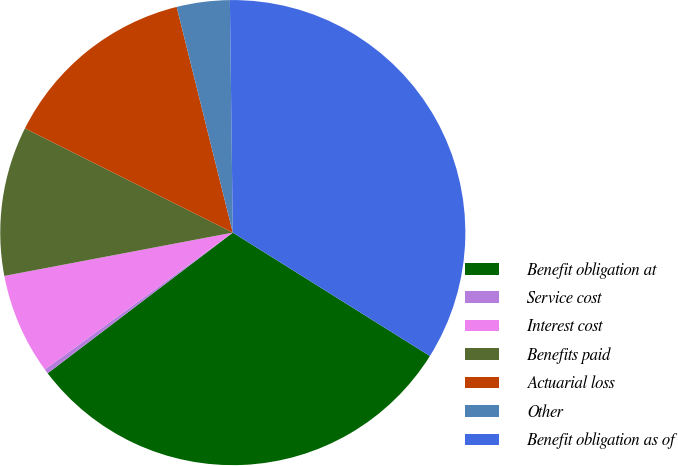Convert chart. <chart><loc_0><loc_0><loc_500><loc_500><pie_chart><fcel>Benefit obligation at<fcel>Service cost<fcel>Interest cost<fcel>Benefits paid<fcel>Actuarial loss<fcel>Other<fcel>Benefit obligation as of<nl><fcel>30.75%<fcel>0.33%<fcel>7.03%<fcel>10.38%<fcel>13.72%<fcel>3.68%<fcel>34.1%<nl></chart> 